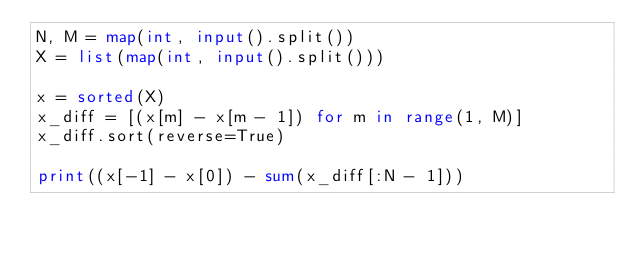Convert code to text. <code><loc_0><loc_0><loc_500><loc_500><_Python_>N, M = map(int, input().split())
X = list(map(int, input().split()))

x = sorted(X)
x_diff = [(x[m] - x[m - 1]) for m in range(1, M)]
x_diff.sort(reverse=True)

print((x[-1] - x[0]) - sum(x_diff[:N - 1]))
</code> 